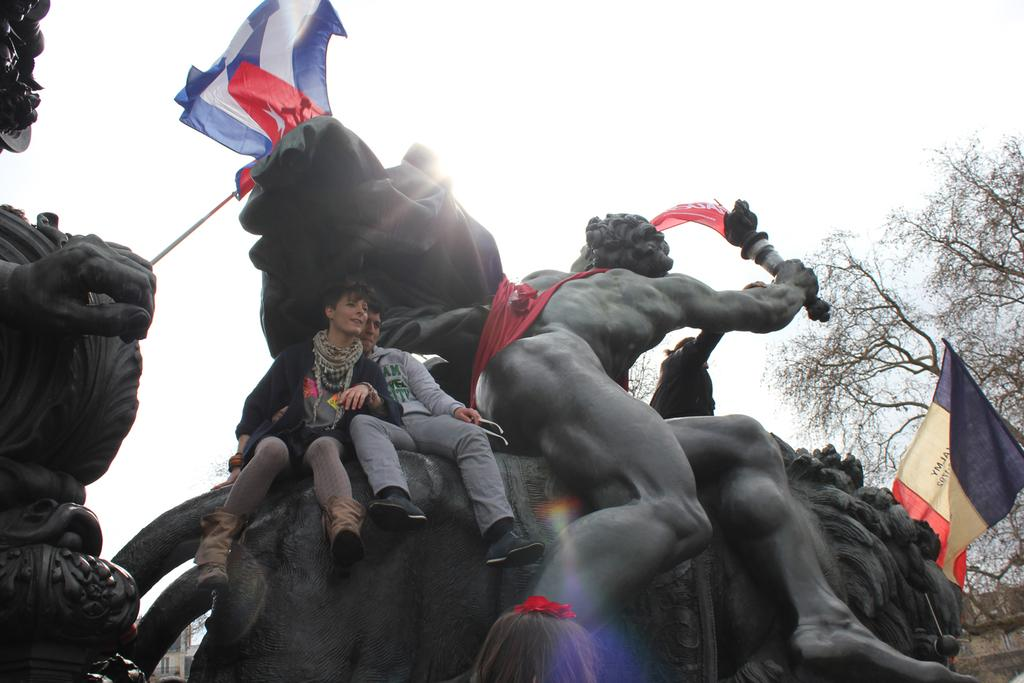What are the two people in the image doing? The two people are sitting on a sculpture. What else can be seen in the image besides the people and sculpture? There are flags and trees visible in the image. What type of worm can be seen crawling on the sister's shoulder in the image? There is no worm or sister present in the image. 